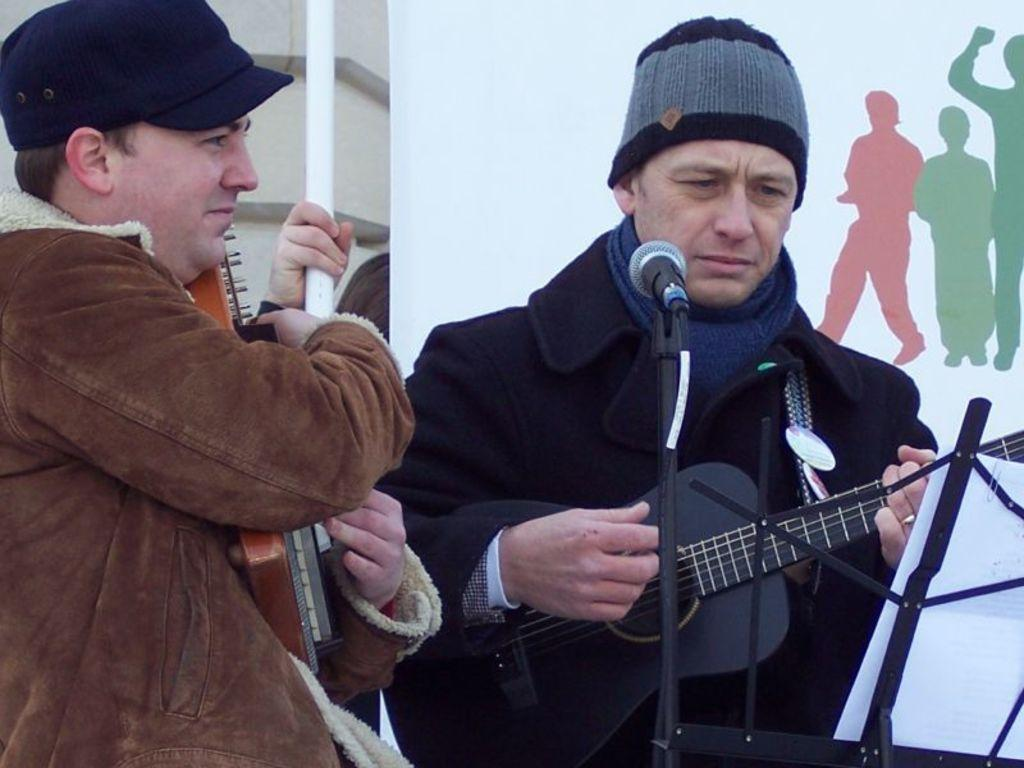How many people are in the image? There are two men in the image. What are the men holding in the image? The men are holding musical instruments. What equipment is present in the image for amplifying sound? There is a microphone with a stand in the image. What is the purpose of the book pad stand in the image? The book pad stand is likely used for holding sheet music or lyrics. Can you describe the person in the background of the image? There is a person in the background of the image, but no specific details are provided. What is written on the banner in the background of the image? The content of the banner is not mentioned in the provided facts. How many clams are visible on the book pad stand in the image? There are no clams present in the image, and they are not mentioned in the provided facts. 